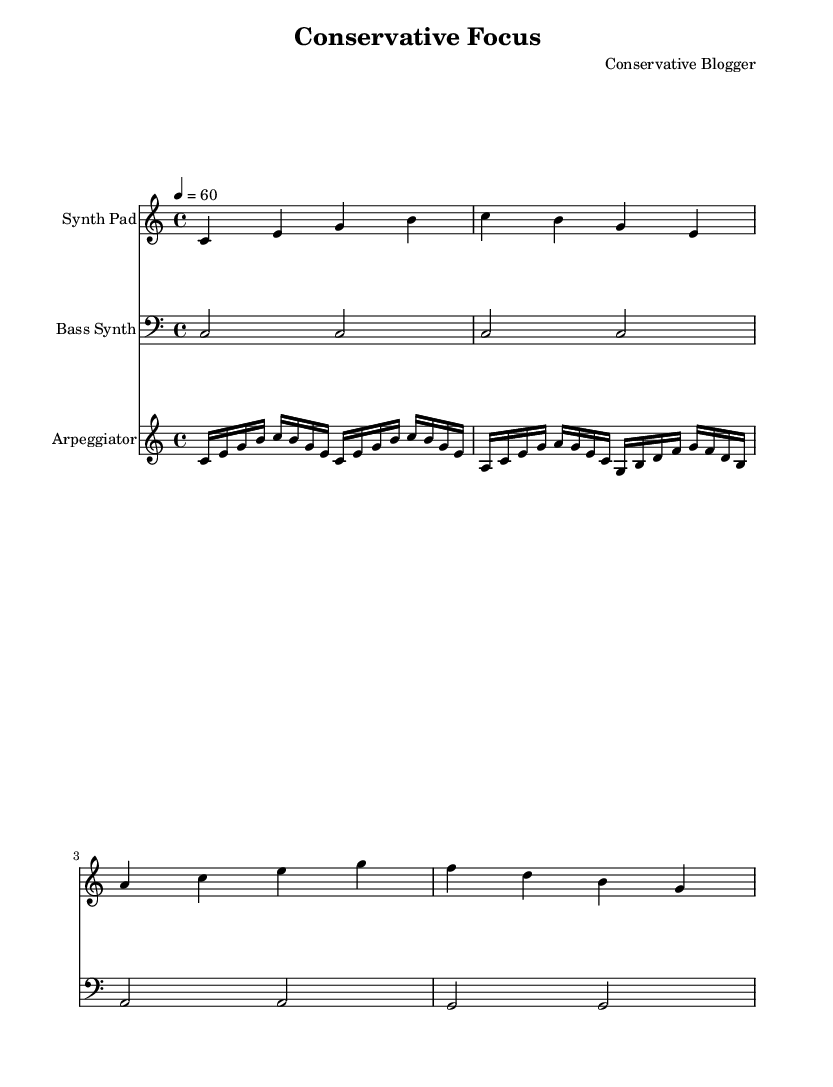What is the key signature of this music? The key signature indicated in the sheet music is C major, which is represented by having no sharps or flats.
Answer: C major What is the time signature of this piece? The time signature shown in the music sheet is 4/4, indicating that there are four beats in each measure and a quarter note receives one beat.
Answer: 4/4 What is the tempo marking for this composition? The tempo marking at the beginning indicates a tempo of 60 beats per minute, which is a moderate pace typically noted as “quarter note = 60.”
Answer: 60 How many measures are there in the "Synth Pad" part? By counting the measures in the "Synth Pad" staff, there are four distinct measures as represented in the notation.
Answer: 4 Which instrument plays the bass part? The bass part is notated in the "Bass Synth" staff, which is specifically indicated for the bass synthesis sounds and notated on a lower clef.
Answer: Bass Synth What pattern is primarily used in the "Arpeggiator" part? The "Arpeggiator" part primarily uses a repeated arpeggio pattern, where the notes are played in succession rather than simultaneously, forming a flowing sound characteristic of electronic music.
Answer: Arpeggio Identify the highest note in the "Synth Pad" part. The highest note played in the "Synth Pad" part is B, which is the highest note present in the first measure of this staff.
Answer: B 